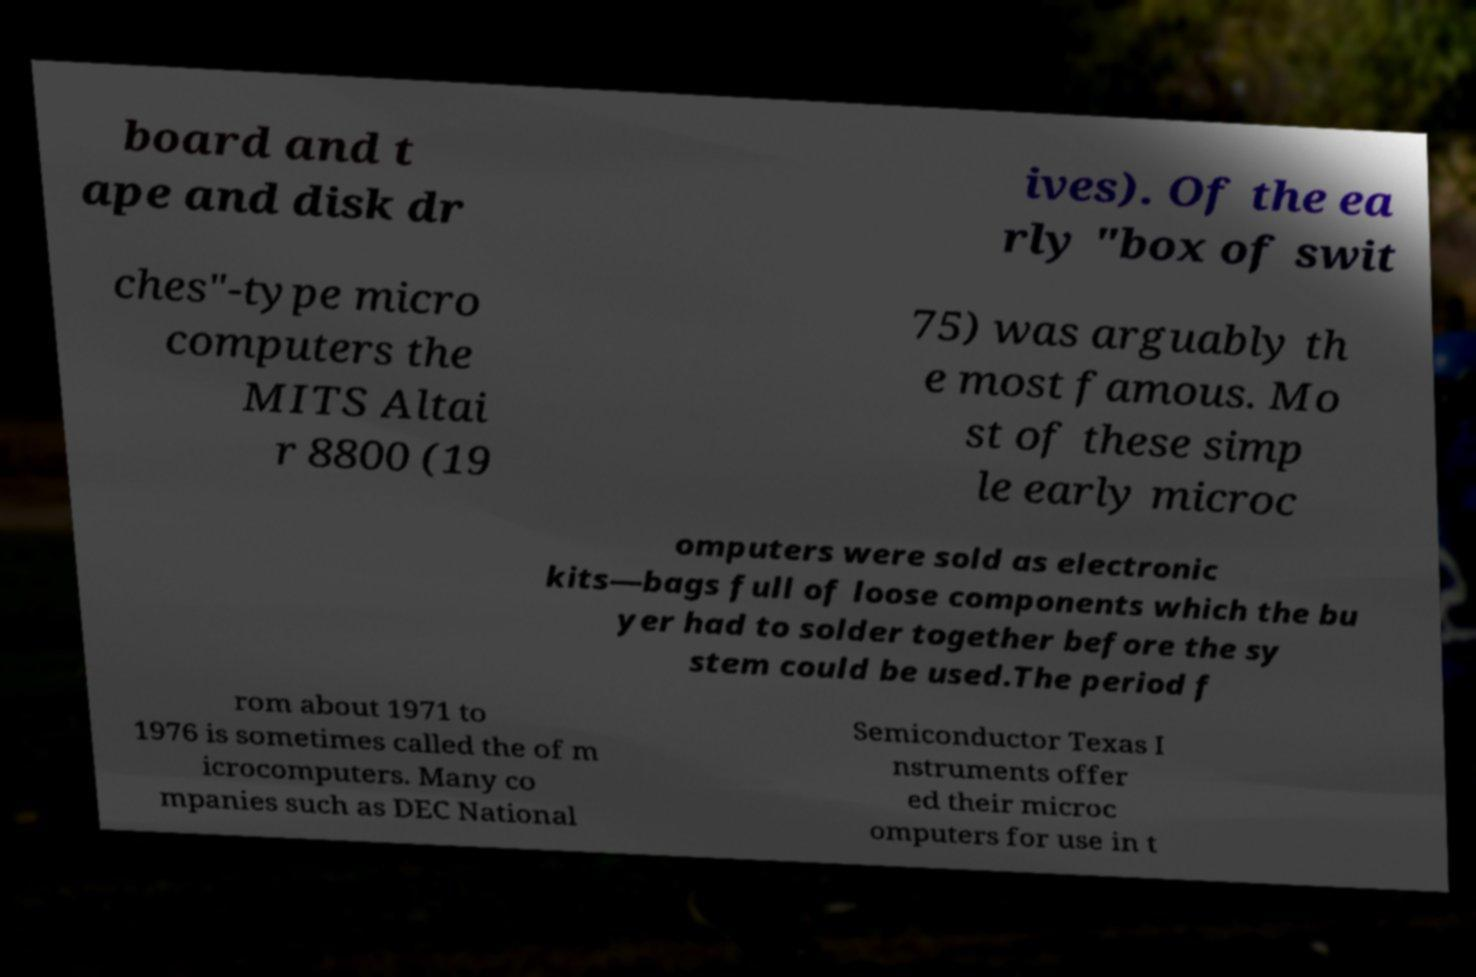Could you assist in decoding the text presented in this image and type it out clearly? board and t ape and disk dr ives). Of the ea rly "box of swit ches"-type micro computers the MITS Altai r 8800 (19 75) was arguably th e most famous. Mo st of these simp le early microc omputers were sold as electronic kits—bags full of loose components which the bu yer had to solder together before the sy stem could be used.The period f rom about 1971 to 1976 is sometimes called the of m icrocomputers. Many co mpanies such as DEC National Semiconductor Texas I nstruments offer ed their microc omputers for use in t 